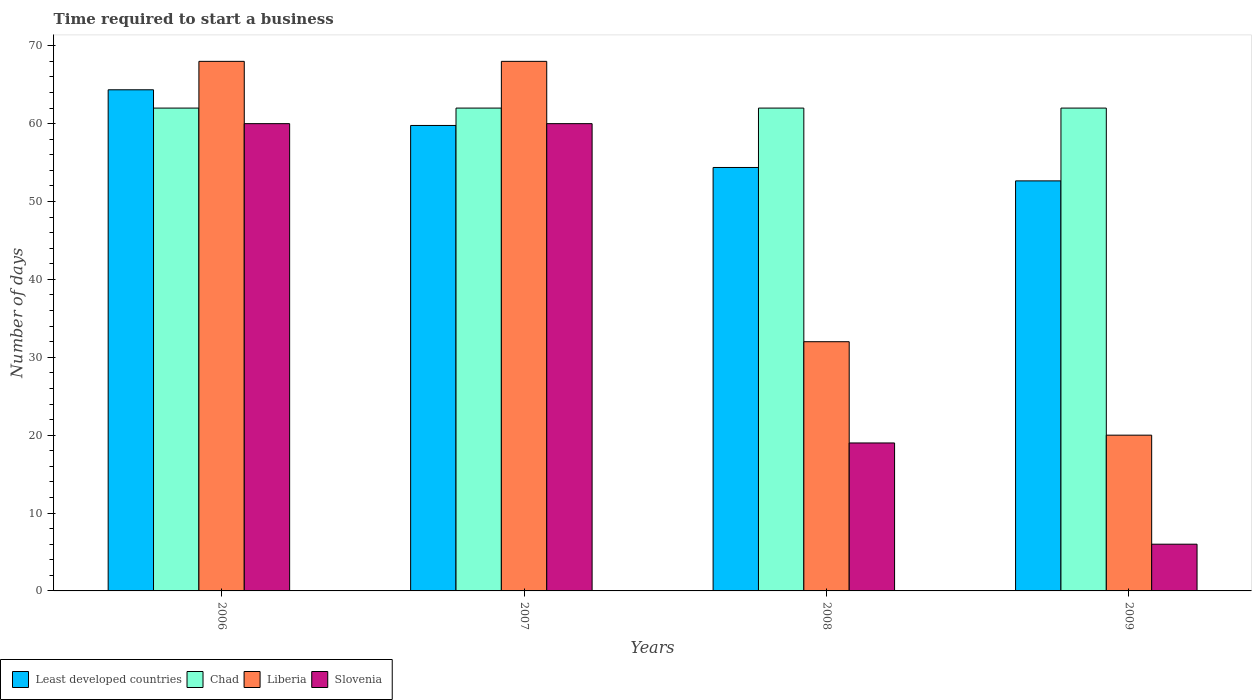How many groups of bars are there?
Your response must be concise. 4. Are the number of bars per tick equal to the number of legend labels?
Your answer should be compact. Yes. How many bars are there on the 2nd tick from the right?
Offer a terse response. 4. What is the label of the 1st group of bars from the left?
Your response must be concise. 2006. What is the number of days required to start a business in Chad in 2009?
Your answer should be very brief. 62. Across all years, what is the maximum number of days required to start a business in Chad?
Provide a succinct answer. 62. What is the total number of days required to start a business in Chad in the graph?
Your answer should be compact. 248. What is the difference between the number of days required to start a business in Least developed countries in 2008 and the number of days required to start a business in Liberia in 2009?
Your answer should be very brief. 34.37. What is the average number of days required to start a business in Least developed countries per year?
Your answer should be very brief. 57.78. In the year 2007, what is the difference between the number of days required to start a business in Liberia and number of days required to start a business in Least developed countries?
Your answer should be compact. 8.23. Is the number of days required to start a business in Chad in 2006 less than that in 2009?
Ensure brevity in your answer.  No. Is the difference between the number of days required to start a business in Liberia in 2007 and 2008 greater than the difference between the number of days required to start a business in Least developed countries in 2007 and 2008?
Make the answer very short. Yes. What is the difference between the highest and the second highest number of days required to start a business in Least developed countries?
Ensure brevity in your answer.  4.58. Is the sum of the number of days required to start a business in Least developed countries in 2007 and 2008 greater than the maximum number of days required to start a business in Chad across all years?
Your response must be concise. Yes. What does the 3rd bar from the left in 2006 represents?
Give a very brief answer. Liberia. What does the 3rd bar from the right in 2008 represents?
Make the answer very short. Chad. How many bars are there?
Make the answer very short. 16. Does the graph contain any zero values?
Your answer should be compact. No. Does the graph contain grids?
Your answer should be very brief. No. How many legend labels are there?
Offer a very short reply. 4. What is the title of the graph?
Provide a short and direct response. Time required to start a business. Does "Upper middle income" appear as one of the legend labels in the graph?
Offer a terse response. No. What is the label or title of the Y-axis?
Make the answer very short. Number of days. What is the Number of days of Least developed countries in 2006?
Your response must be concise. 64.35. What is the Number of days of Chad in 2006?
Provide a short and direct response. 62. What is the Number of days of Slovenia in 2006?
Offer a terse response. 60. What is the Number of days of Least developed countries in 2007?
Your response must be concise. 59.77. What is the Number of days of Least developed countries in 2008?
Ensure brevity in your answer.  54.37. What is the Number of days in Least developed countries in 2009?
Give a very brief answer. 52.65. What is the Number of days of Slovenia in 2009?
Provide a succinct answer. 6. Across all years, what is the maximum Number of days of Least developed countries?
Provide a short and direct response. 64.35. Across all years, what is the minimum Number of days in Least developed countries?
Keep it short and to the point. 52.65. Across all years, what is the minimum Number of days in Slovenia?
Keep it short and to the point. 6. What is the total Number of days of Least developed countries in the graph?
Your answer should be very brief. 231.14. What is the total Number of days in Chad in the graph?
Give a very brief answer. 248. What is the total Number of days in Liberia in the graph?
Offer a very short reply. 188. What is the total Number of days of Slovenia in the graph?
Offer a very short reply. 145. What is the difference between the Number of days of Least developed countries in 2006 and that in 2007?
Your response must be concise. 4.58. What is the difference between the Number of days in Chad in 2006 and that in 2007?
Your answer should be very brief. 0. What is the difference between the Number of days of Slovenia in 2006 and that in 2007?
Make the answer very short. 0. What is the difference between the Number of days of Least developed countries in 2006 and that in 2008?
Provide a short and direct response. 9.98. What is the difference between the Number of days of Liberia in 2006 and that in 2008?
Offer a terse response. 36. What is the difference between the Number of days of Slovenia in 2006 and that in 2008?
Give a very brief answer. 41. What is the difference between the Number of days of Least developed countries in 2006 and that in 2009?
Offer a terse response. 11.7. What is the difference between the Number of days of Liberia in 2006 and that in 2009?
Keep it short and to the point. 48. What is the difference between the Number of days of Slovenia in 2006 and that in 2009?
Provide a short and direct response. 54. What is the difference between the Number of days of Least developed countries in 2007 and that in 2008?
Ensure brevity in your answer.  5.4. What is the difference between the Number of days in Liberia in 2007 and that in 2008?
Give a very brief answer. 36. What is the difference between the Number of days of Least developed countries in 2007 and that in 2009?
Your answer should be very brief. 7.12. What is the difference between the Number of days in Liberia in 2007 and that in 2009?
Provide a short and direct response. 48. What is the difference between the Number of days of Slovenia in 2007 and that in 2009?
Make the answer very short. 54. What is the difference between the Number of days in Least developed countries in 2008 and that in 2009?
Make the answer very short. 1.72. What is the difference between the Number of days of Chad in 2008 and that in 2009?
Offer a very short reply. 0. What is the difference between the Number of days of Liberia in 2008 and that in 2009?
Your response must be concise. 12. What is the difference between the Number of days of Least developed countries in 2006 and the Number of days of Chad in 2007?
Give a very brief answer. 2.35. What is the difference between the Number of days in Least developed countries in 2006 and the Number of days in Liberia in 2007?
Offer a terse response. -3.65. What is the difference between the Number of days of Least developed countries in 2006 and the Number of days of Slovenia in 2007?
Make the answer very short. 4.35. What is the difference between the Number of days in Chad in 2006 and the Number of days in Slovenia in 2007?
Offer a terse response. 2. What is the difference between the Number of days of Liberia in 2006 and the Number of days of Slovenia in 2007?
Offer a very short reply. 8. What is the difference between the Number of days of Least developed countries in 2006 and the Number of days of Chad in 2008?
Keep it short and to the point. 2.35. What is the difference between the Number of days in Least developed countries in 2006 and the Number of days in Liberia in 2008?
Provide a short and direct response. 32.35. What is the difference between the Number of days of Least developed countries in 2006 and the Number of days of Slovenia in 2008?
Your response must be concise. 45.35. What is the difference between the Number of days in Chad in 2006 and the Number of days in Slovenia in 2008?
Your answer should be compact. 43. What is the difference between the Number of days in Least developed countries in 2006 and the Number of days in Chad in 2009?
Your answer should be very brief. 2.35. What is the difference between the Number of days of Least developed countries in 2006 and the Number of days of Liberia in 2009?
Offer a very short reply. 44.35. What is the difference between the Number of days in Least developed countries in 2006 and the Number of days in Slovenia in 2009?
Provide a short and direct response. 58.35. What is the difference between the Number of days of Chad in 2006 and the Number of days of Liberia in 2009?
Provide a short and direct response. 42. What is the difference between the Number of days in Chad in 2006 and the Number of days in Slovenia in 2009?
Give a very brief answer. 56. What is the difference between the Number of days of Least developed countries in 2007 and the Number of days of Chad in 2008?
Keep it short and to the point. -2.23. What is the difference between the Number of days in Least developed countries in 2007 and the Number of days in Liberia in 2008?
Keep it short and to the point. 27.77. What is the difference between the Number of days in Least developed countries in 2007 and the Number of days in Slovenia in 2008?
Give a very brief answer. 40.77. What is the difference between the Number of days of Least developed countries in 2007 and the Number of days of Chad in 2009?
Keep it short and to the point. -2.23. What is the difference between the Number of days of Least developed countries in 2007 and the Number of days of Liberia in 2009?
Keep it short and to the point. 39.77. What is the difference between the Number of days of Least developed countries in 2007 and the Number of days of Slovenia in 2009?
Make the answer very short. 53.77. What is the difference between the Number of days in Chad in 2007 and the Number of days in Liberia in 2009?
Your answer should be very brief. 42. What is the difference between the Number of days in Chad in 2007 and the Number of days in Slovenia in 2009?
Ensure brevity in your answer.  56. What is the difference between the Number of days of Least developed countries in 2008 and the Number of days of Chad in 2009?
Give a very brief answer. -7.63. What is the difference between the Number of days in Least developed countries in 2008 and the Number of days in Liberia in 2009?
Your answer should be compact. 34.37. What is the difference between the Number of days of Least developed countries in 2008 and the Number of days of Slovenia in 2009?
Ensure brevity in your answer.  48.37. What is the difference between the Number of days of Chad in 2008 and the Number of days of Liberia in 2009?
Provide a succinct answer. 42. What is the difference between the Number of days of Chad in 2008 and the Number of days of Slovenia in 2009?
Keep it short and to the point. 56. What is the difference between the Number of days of Liberia in 2008 and the Number of days of Slovenia in 2009?
Your answer should be very brief. 26. What is the average Number of days in Least developed countries per year?
Ensure brevity in your answer.  57.78. What is the average Number of days in Liberia per year?
Ensure brevity in your answer.  47. What is the average Number of days of Slovenia per year?
Provide a succinct answer. 36.25. In the year 2006, what is the difference between the Number of days of Least developed countries and Number of days of Chad?
Offer a terse response. 2.35. In the year 2006, what is the difference between the Number of days of Least developed countries and Number of days of Liberia?
Provide a succinct answer. -3.65. In the year 2006, what is the difference between the Number of days in Least developed countries and Number of days in Slovenia?
Provide a short and direct response. 4.35. In the year 2006, what is the difference between the Number of days in Chad and Number of days in Liberia?
Offer a terse response. -6. In the year 2006, what is the difference between the Number of days of Chad and Number of days of Slovenia?
Offer a very short reply. 2. In the year 2007, what is the difference between the Number of days in Least developed countries and Number of days in Chad?
Make the answer very short. -2.23. In the year 2007, what is the difference between the Number of days in Least developed countries and Number of days in Liberia?
Provide a short and direct response. -8.23. In the year 2007, what is the difference between the Number of days in Least developed countries and Number of days in Slovenia?
Ensure brevity in your answer.  -0.23. In the year 2007, what is the difference between the Number of days of Chad and Number of days of Slovenia?
Make the answer very short. 2. In the year 2008, what is the difference between the Number of days in Least developed countries and Number of days in Chad?
Ensure brevity in your answer.  -7.63. In the year 2008, what is the difference between the Number of days in Least developed countries and Number of days in Liberia?
Your answer should be compact. 22.37. In the year 2008, what is the difference between the Number of days of Least developed countries and Number of days of Slovenia?
Provide a short and direct response. 35.37. In the year 2008, what is the difference between the Number of days of Chad and Number of days of Slovenia?
Provide a succinct answer. 43. In the year 2009, what is the difference between the Number of days in Least developed countries and Number of days in Chad?
Your answer should be very brief. -9.35. In the year 2009, what is the difference between the Number of days of Least developed countries and Number of days of Liberia?
Keep it short and to the point. 32.65. In the year 2009, what is the difference between the Number of days of Least developed countries and Number of days of Slovenia?
Your answer should be very brief. 46.65. In the year 2009, what is the difference between the Number of days of Chad and Number of days of Liberia?
Provide a short and direct response. 42. In the year 2009, what is the difference between the Number of days of Chad and Number of days of Slovenia?
Provide a short and direct response. 56. In the year 2009, what is the difference between the Number of days in Liberia and Number of days in Slovenia?
Your answer should be very brief. 14. What is the ratio of the Number of days in Least developed countries in 2006 to that in 2007?
Provide a short and direct response. 1.08. What is the ratio of the Number of days in Chad in 2006 to that in 2007?
Your response must be concise. 1. What is the ratio of the Number of days of Liberia in 2006 to that in 2007?
Your answer should be compact. 1. What is the ratio of the Number of days of Slovenia in 2006 to that in 2007?
Provide a succinct answer. 1. What is the ratio of the Number of days in Least developed countries in 2006 to that in 2008?
Offer a very short reply. 1.18. What is the ratio of the Number of days of Liberia in 2006 to that in 2008?
Ensure brevity in your answer.  2.12. What is the ratio of the Number of days of Slovenia in 2006 to that in 2008?
Ensure brevity in your answer.  3.16. What is the ratio of the Number of days in Least developed countries in 2006 to that in 2009?
Your answer should be very brief. 1.22. What is the ratio of the Number of days in Liberia in 2006 to that in 2009?
Ensure brevity in your answer.  3.4. What is the ratio of the Number of days in Slovenia in 2006 to that in 2009?
Your response must be concise. 10. What is the ratio of the Number of days in Least developed countries in 2007 to that in 2008?
Provide a short and direct response. 1.1. What is the ratio of the Number of days of Liberia in 2007 to that in 2008?
Offer a very short reply. 2.12. What is the ratio of the Number of days of Slovenia in 2007 to that in 2008?
Ensure brevity in your answer.  3.16. What is the ratio of the Number of days of Least developed countries in 2007 to that in 2009?
Your answer should be very brief. 1.14. What is the ratio of the Number of days in Chad in 2007 to that in 2009?
Offer a terse response. 1. What is the ratio of the Number of days of Slovenia in 2007 to that in 2009?
Make the answer very short. 10. What is the ratio of the Number of days in Least developed countries in 2008 to that in 2009?
Offer a very short reply. 1.03. What is the ratio of the Number of days of Chad in 2008 to that in 2009?
Give a very brief answer. 1. What is the ratio of the Number of days of Slovenia in 2008 to that in 2009?
Provide a succinct answer. 3.17. What is the difference between the highest and the second highest Number of days of Least developed countries?
Give a very brief answer. 4.58. What is the difference between the highest and the second highest Number of days in Chad?
Your answer should be very brief. 0. What is the difference between the highest and the lowest Number of days of Least developed countries?
Offer a very short reply. 11.7. 